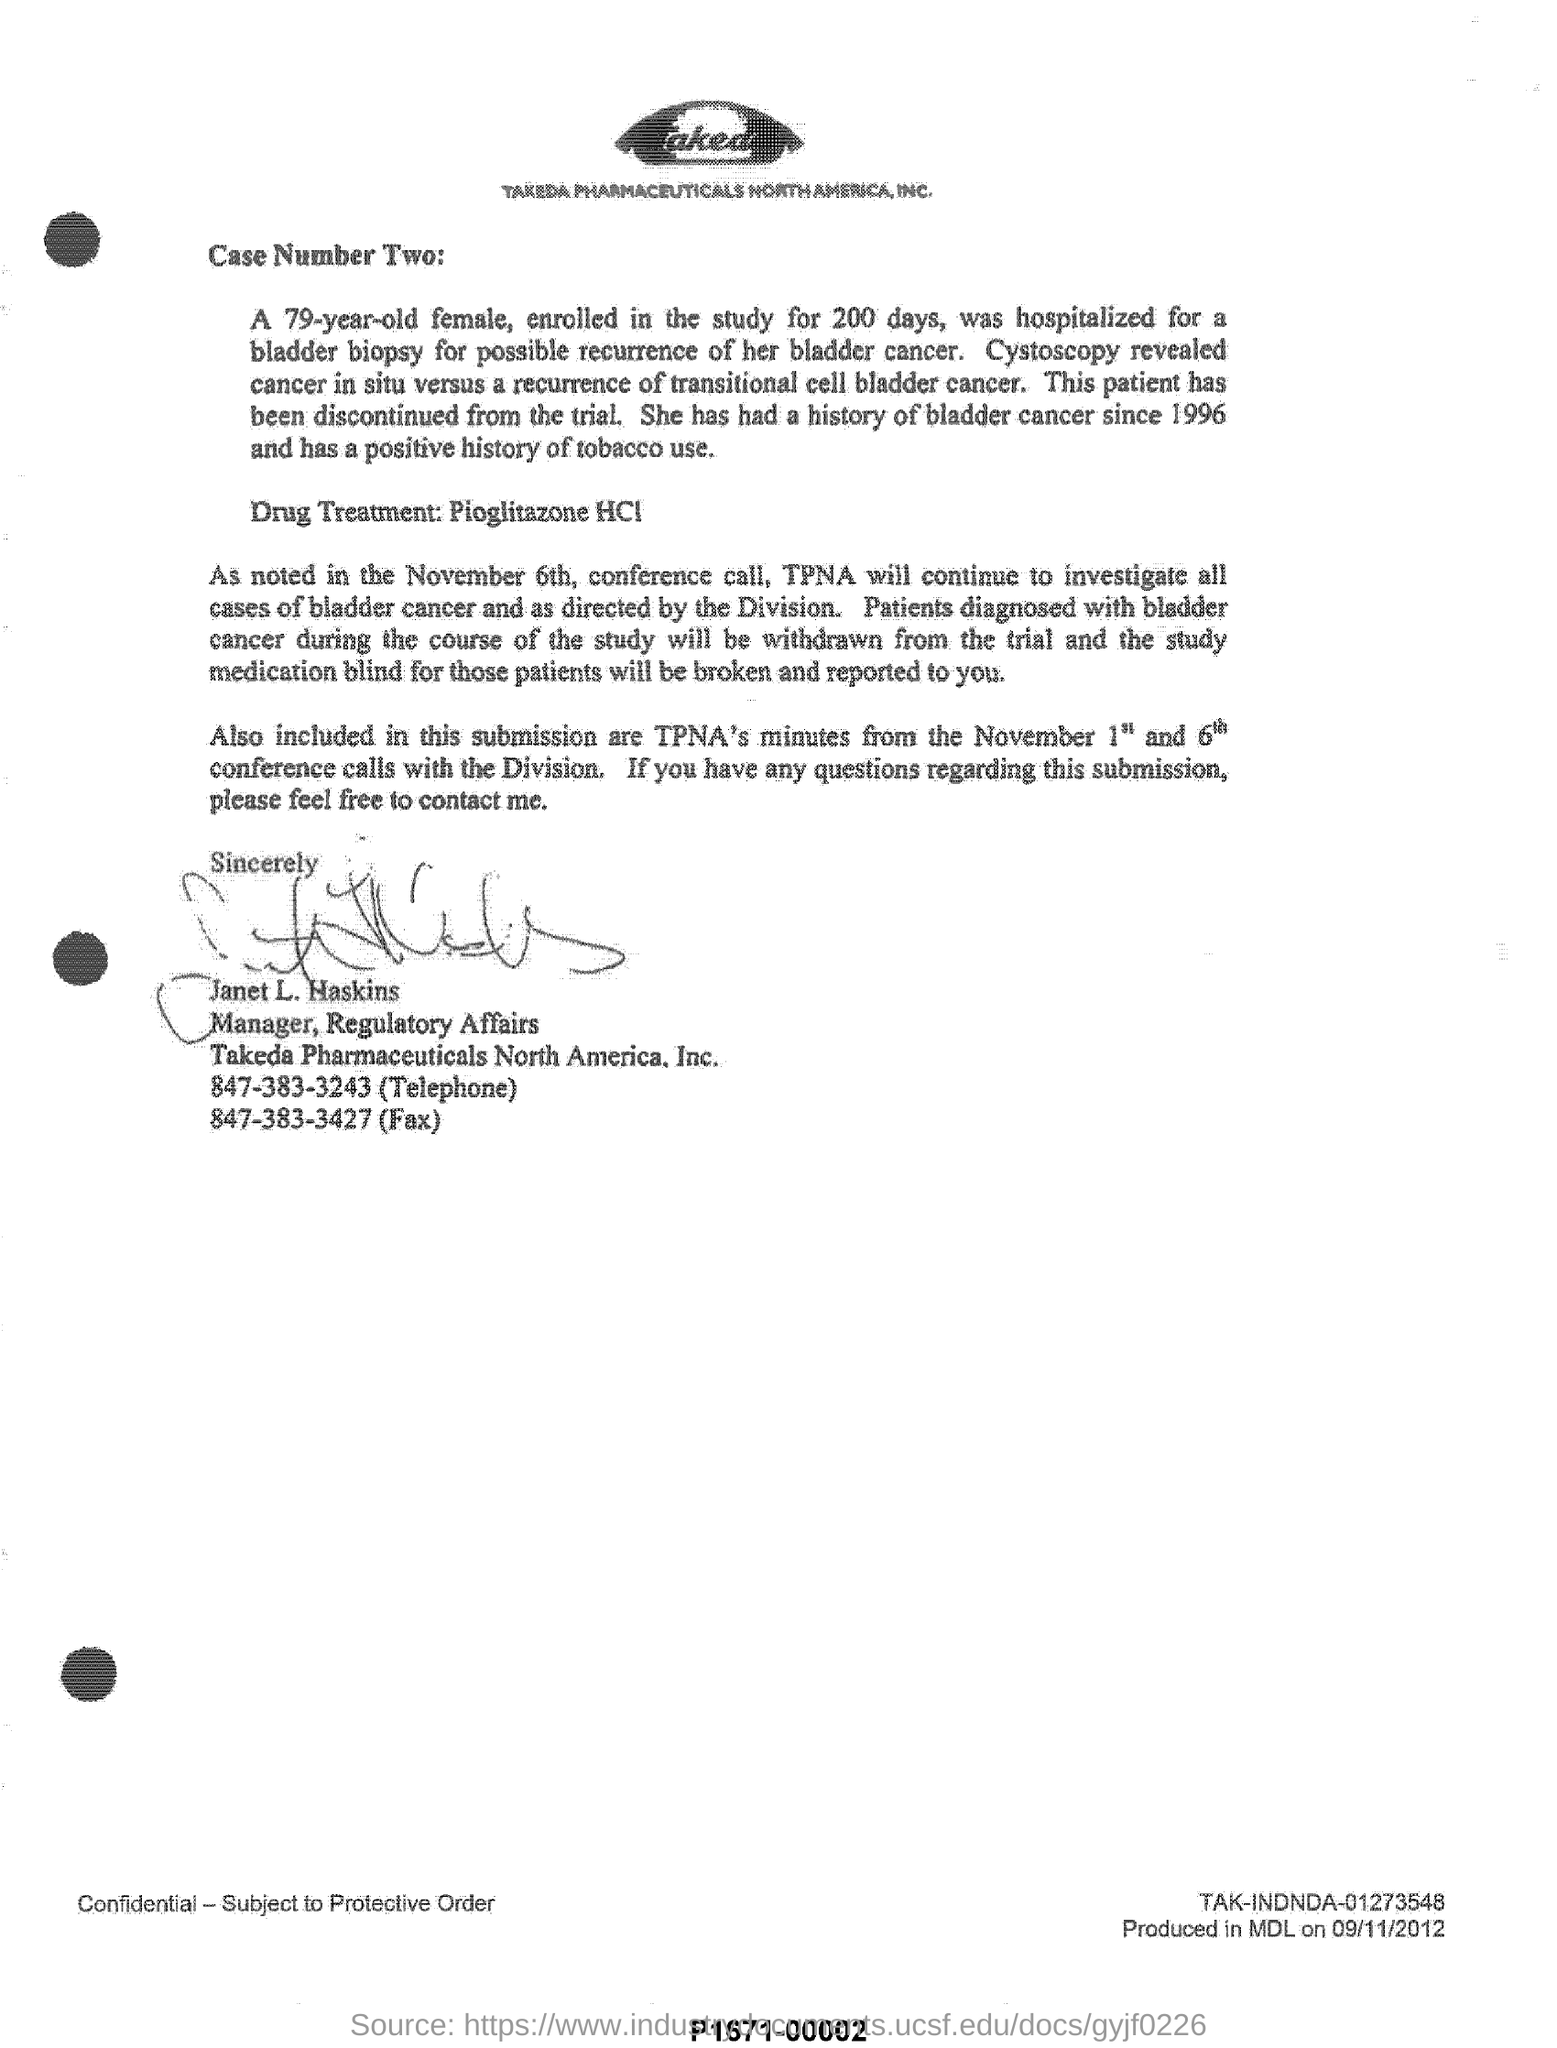Identify some key points in this picture. The writer of the document is Janet L. Haskins. The patient has a history of bladder cancer dating back to 1996. A 79-year-old female participated in the study for a period of 200 days. The woman had a history of using tobacco in a positive manner. 